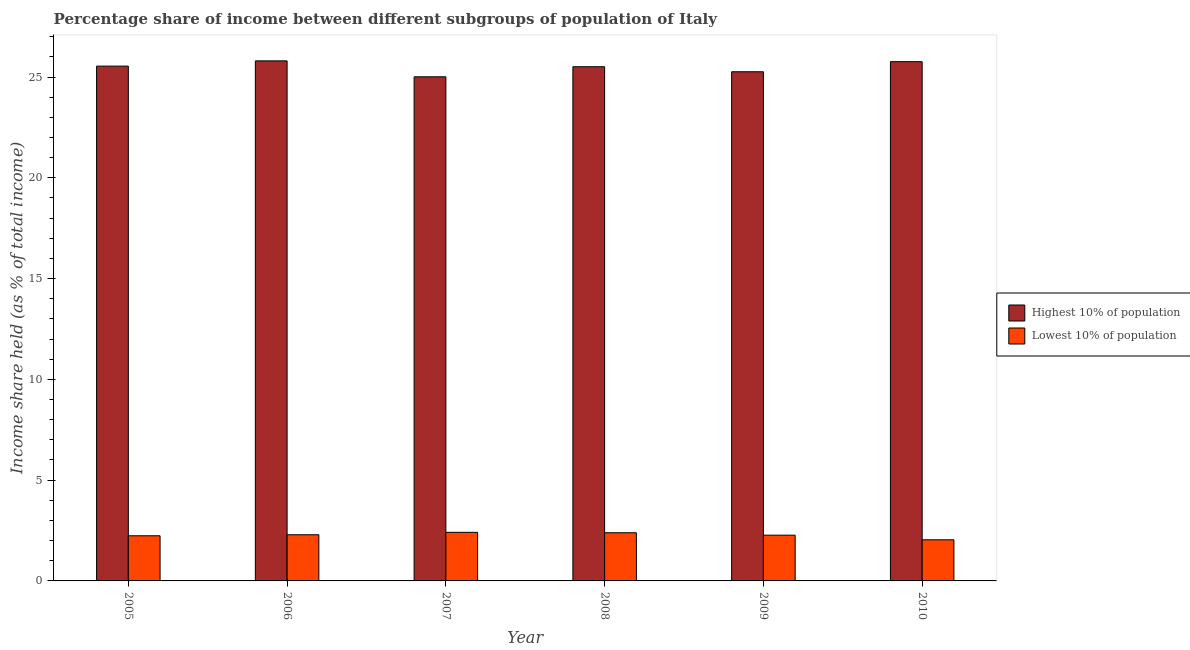How many different coloured bars are there?
Make the answer very short. 2. How many groups of bars are there?
Offer a very short reply. 6. What is the label of the 3rd group of bars from the left?
Offer a very short reply. 2007. What is the income share held by highest 10% of the population in 2008?
Provide a short and direct response. 25.51. Across all years, what is the maximum income share held by highest 10% of the population?
Offer a very short reply. 25.8. Across all years, what is the minimum income share held by lowest 10% of the population?
Your answer should be compact. 2.04. In which year was the income share held by highest 10% of the population minimum?
Offer a terse response. 2007. What is the total income share held by highest 10% of the population in the graph?
Ensure brevity in your answer.  152.88. What is the difference between the income share held by lowest 10% of the population in 2006 and that in 2009?
Provide a succinct answer. 0.02. What is the difference between the income share held by highest 10% of the population in 2005 and the income share held by lowest 10% of the population in 2006?
Provide a succinct answer. -0.26. What is the average income share held by highest 10% of the population per year?
Your answer should be compact. 25.48. In the year 2007, what is the difference between the income share held by lowest 10% of the population and income share held by highest 10% of the population?
Provide a short and direct response. 0. In how many years, is the income share held by highest 10% of the population greater than 1 %?
Make the answer very short. 6. What is the ratio of the income share held by lowest 10% of the population in 2007 to that in 2008?
Give a very brief answer. 1.01. What is the difference between the highest and the second highest income share held by highest 10% of the population?
Offer a very short reply. 0.04. What is the difference between the highest and the lowest income share held by highest 10% of the population?
Provide a short and direct response. 0.79. In how many years, is the income share held by lowest 10% of the population greater than the average income share held by lowest 10% of the population taken over all years?
Your answer should be compact. 3. What does the 2nd bar from the left in 2009 represents?
Keep it short and to the point. Lowest 10% of population. What does the 1st bar from the right in 2009 represents?
Offer a terse response. Lowest 10% of population. How many bars are there?
Your answer should be compact. 12. How many years are there in the graph?
Your answer should be very brief. 6. What is the difference between two consecutive major ticks on the Y-axis?
Ensure brevity in your answer.  5. Does the graph contain grids?
Your response must be concise. No. Where does the legend appear in the graph?
Your answer should be compact. Center right. What is the title of the graph?
Provide a succinct answer. Percentage share of income between different subgroups of population of Italy. Does "Arms imports" appear as one of the legend labels in the graph?
Your answer should be compact. No. What is the label or title of the Y-axis?
Ensure brevity in your answer.  Income share held (as % of total income). What is the Income share held (as % of total income) in Highest 10% of population in 2005?
Your answer should be compact. 25.54. What is the Income share held (as % of total income) in Lowest 10% of population in 2005?
Ensure brevity in your answer.  2.24. What is the Income share held (as % of total income) in Highest 10% of population in 2006?
Provide a succinct answer. 25.8. What is the Income share held (as % of total income) in Lowest 10% of population in 2006?
Your answer should be compact. 2.29. What is the Income share held (as % of total income) of Highest 10% of population in 2007?
Offer a terse response. 25.01. What is the Income share held (as % of total income) in Lowest 10% of population in 2007?
Provide a short and direct response. 2.41. What is the Income share held (as % of total income) of Highest 10% of population in 2008?
Offer a terse response. 25.51. What is the Income share held (as % of total income) in Lowest 10% of population in 2008?
Make the answer very short. 2.39. What is the Income share held (as % of total income) of Highest 10% of population in 2009?
Make the answer very short. 25.26. What is the Income share held (as % of total income) in Lowest 10% of population in 2009?
Give a very brief answer. 2.27. What is the Income share held (as % of total income) in Highest 10% of population in 2010?
Give a very brief answer. 25.76. What is the Income share held (as % of total income) in Lowest 10% of population in 2010?
Provide a short and direct response. 2.04. Across all years, what is the maximum Income share held (as % of total income) of Highest 10% of population?
Offer a very short reply. 25.8. Across all years, what is the maximum Income share held (as % of total income) in Lowest 10% of population?
Make the answer very short. 2.41. Across all years, what is the minimum Income share held (as % of total income) in Highest 10% of population?
Your response must be concise. 25.01. Across all years, what is the minimum Income share held (as % of total income) of Lowest 10% of population?
Your answer should be compact. 2.04. What is the total Income share held (as % of total income) in Highest 10% of population in the graph?
Your response must be concise. 152.88. What is the total Income share held (as % of total income) in Lowest 10% of population in the graph?
Your answer should be compact. 13.64. What is the difference between the Income share held (as % of total income) in Highest 10% of population in 2005 and that in 2006?
Provide a succinct answer. -0.26. What is the difference between the Income share held (as % of total income) of Lowest 10% of population in 2005 and that in 2006?
Make the answer very short. -0.05. What is the difference between the Income share held (as % of total income) of Highest 10% of population in 2005 and that in 2007?
Keep it short and to the point. 0.53. What is the difference between the Income share held (as % of total income) of Lowest 10% of population in 2005 and that in 2007?
Provide a short and direct response. -0.17. What is the difference between the Income share held (as % of total income) of Highest 10% of population in 2005 and that in 2008?
Your response must be concise. 0.03. What is the difference between the Income share held (as % of total income) of Lowest 10% of population in 2005 and that in 2008?
Ensure brevity in your answer.  -0.15. What is the difference between the Income share held (as % of total income) in Highest 10% of population in 2005 and that in 2009?
Ensure brevity in your answer.  0.28. What is the difference between the Income share held (as % of total income) of Lowest 10% of population in 2005 and that in 2009?
Provide a short and direct response. -0.03. What is the difference between the Income share held (as % of total income) in Highest 10% of population in 2005 and that in 2010?
Offer a terse response. -0.22. What is the difference between the Income share held (as % of total income) of Lowest 10% of population in 2005 and that in 2010?
Provide a succinct answer. 0.2. What is the difference between the Income share held (as % of total income) of Highest 10% of population in 2006 and that in 2007?
Offer a terse response. 0.79. What is the difference between the Income share held (as % of total income) of Lowest 10% of population in 2006 and that in 2007?
Provide a short and direct response. -0.12. What is the difference between the Income share held (as % of total income) of Highest 10% of population in 2006 and that in 2008?
Your response must be concise. 0.29. What is the difference between the Income share held (as % of total income) in Lowest 10% of population in 2006 and that in 2008?
Your response must be concise. -0.1. What is the difference between the Income share held (as % of total income) of Highest 10% of population in 2006 and that in 2009?
Your answer should be very brief. 0.54. What is the difference between the Income share held (as % of total income) in Highest 10% of population in 2006 and that in 2010?
Give a very brief answer. 0.04. What is the difference between the Income share held (as % of total income) of Highest 10% of population in 2007 and that in 2008?
Provide a succinct answer. -0.5. What is the difference between the Income share held (as % of total income) of Lowest 10% of population in 2007 and that in 2008?
Provide a short and direct response. 0.02. What is the difference between the Income share held (as % of total income) of Lowest 10% of population in 2007 and that in 2009?
Provide a short and direct response. 0.14. What is the difference between the Income share held (as % of total income) of Highest 10% of population in 2007 and that in 2010?
Make the answer very short. -0.75. What is the difference between the Income share held (as % of total income) in Lowest 10% of population in 2007 and that in 2010?
Offer a terse response. 0.37. What is the difference between the Income share held (as % of total income) of Highest 10% of population in 2008 and that in 2009?
Give a very brief answer. 0.25. What is the difference between the Income share held (as % of total income) in Lowest 10% of population in 2008 and that in 2009?
Offer a terse response. 0.12. What is the difference between the Income share held (as % of total income) in Lowest 10% of population in 2009 and that in 2010?
Provide a short and direct response. 0.23. What is the difference between the Income share held (as % of total income) in Highest 10% of population in 2005 and the Income share held (as % of total income) in Lowest 10% of population in 2006?
Keep it short and to the point. 23.25. What is the difference between the Income share held (as % of total income) of Highest 10% of population in 2005 and the Income share held (as % of total income) of Lowest 10% of population in 2007?
Ensure brevity in your answer.  23.13. What is the difference between the Income share held (as % of total income) in Highest 10% of population in 2005 and the Income share held (as % of total income) in Lowest 10% of population in 2008?
Your answer should be compact. 23.15. What is the difference between the Income share held (as % of total income) of Highest 10% of population in 2005 and the Income share held (as % of total income) of Lowest 10% of population in 2009?
Give a very brief answer. 23.27. What is the difference between the Income share held (as % of total income) in Highest 10% of population in 2006 and the Income share held (as % of total income) in Lowest 10% of population in 2007?
Keep it short and to the point. 23.39. What is the difference between the Income share held (as % of total income) in Highest 10% of population in 2006 and the Income share held (as % of total income) in Lowest 10% of population in 2008?
Your answer should be very brief. 23.41. What is the difference between the Income share held (as % of total income) of Highest 10% of population in 2006 and the Income share held (as % of total income) of Lowest 10% of population in 2009?
Provide a short and direct response. 23.53. What is the difference between the Income share held (as % of total income) of Highest 10% of population in 2006 and the Income share held (as % of total income) of Lowest 10% of population in 2010?
Your answer should be very brief. 23.76. What is the difference between the Income share held (as % of total income) of Highest 10% of population in 2007 and the Income share held (as % of total income) of Lowest 10% of population in 2008?
Make the answer very short. 22.62. What is the difference between the Income share held (as % of total income) in Highest 10% of population in 2007 and the Income share held (as % of total income) in Lowest 10% of population in 2009?
Your answer should be compact. 22.74. What is the difference between the Income share held (as % of total income) of Highest 10% of population in 2007 and the Income share held (as % of total income) of Lowest 10% of population in 2010?
Your answer should be very brief. 22.97. What is the difference between the Income share held (as % of total income) in Highest 10% of population in 2008 and the Income share held (as % of total income) in Lowest 10% of population in 2009?
Make the answer very short. 23.24. What is the difference between the Income share held (as % of total income) in Highest 10% of population in 2008 and the Income share held (as % of total income) in Lowest 10% of population in 2010?
Make the answer very short. 23.47. What is the difference between the Income share held (as % of total income) in Highest 10% of population in 2009 and the Income share held (as % of total income) in Lowest 10% of population in 2010?
Your response must be concise. 23.22. What is the average Income share held (as % of total income) of Highest 10% of population per year?
Offer a very short reply. 25.48. What is the average Income share held (as % of total income) of Lowest 10% of population per year?
Ensure brevity in your answer.  2.27. In the year 2005, what is the difference between the Income share held (as % of total income) of Highest 10% of population and Income share held (as % of total income) of Lowest 10% of population?
Your answer should be compact. 23.3. In the year 2006, what is the difference between the Income share held (as % of total income) in Highest 10% of population and Income share held (as % of total income) in Lowest 10% of population?
Your answer should be very brief. 23.51. In the year 2007, what is the difference between the Income share held (as % of total income) of Highest 10% of population and Income share held (as % of total income) of Lowest 10% of population?
Your response must be concise. 22.6. In the year 2008, what is the difference between the Income share held (as % of total income) of Highest 10% of population and Income share held (as % of total income) of Lowest 10% of population?
Make the answer very short. 23.12. In the year 2009, what is the difference between the Income share held (as % of total income) in Highest 10% of population and Income share held (as % of total income) in Lowest 10% of population?
Make the answer very short. 22.99. In the year 2010, what is the difference between the Income share held (as % of total income) in Highest 10% of population and Income share held (as % of total income) in Lowest 10% of population?
Give a very brief answer. 23.72. What is the ratio of the Income share held (as % of total income) of Highest 10% of population in 2005 to that in 2006?
Keep it short and to the point. 0.99. What is the ratio of the Income share held (as % of total income) in Lowest 10% of population in 2005 to that in 2006?
Your answer should be compact. 0.98. What is the ratio of the Income share held (as % of total income) in Highest 10% of population in 2005 to that in 2007?
Keep it short and to the point. 1.02. What is the ratio of the Income share held (as % of total income) of Lowest 10% of population in 2005 to that in 2007?
Offer a terse response. 0.93. What is the ratio of the Income share held (as % of total income) of Lowest 10% of population in 2005 to that in 2008?
Keep it short and to the point. 0.94. What is the ratio of the Income share held (as % of total income) in Highest 10% of population in 2005 to that in 2009?
Offer a very short reply. 1.01. What is the ratio of the Income share held (as % of total income) of Lowest 10% of population in 2005 to that in 2009?
Give a very brief answer. 0.99. What is the ratio of the Income share held (as % of total income) of Highest 10% of population in 2005 to that in 2010?
Your answer should be compact. 0.99. What is the ratio of the Income share held (as % of total income) in Lowest 10% of population in 2005 to that in 2010?
Keep it short and to the point. 1.1. What is the ratio of the Income share held (as % of total income) of Highest 10% of population in 2006 to that in 2007?
Your answer should be compact. 1.03. What is the ratio of the Income share held (as % of total income) in Lowest 10% of population in 2006 to that in 2007?
Provide a short and direct response. 0.95. What is the ratio of the Income share held (as % of total income) of Highest 10% of population in 2006 to that in 2008?
Ensure brevity in your answer.  1.01. What is the ratio of the Income share held (as % of total income) of Lowest 10% of population in 2006 to that in 2008?
Your answer should be compact. 0.96. What is the ratio of the Income share held (as % of total income) of Highest 10% of population in 2006 to that in 2009?
Provide a succinct answer. 1.02. What is the ratio of the Income share held (as % of total income) of Lowest 10% of population in 2006 to that in 2009?
Your answer should be compact. 1.01. What is the ratio of the Income share held (as % of total income) of Highest 10% of population in 2006 to that in 2010?
Provide a succinct answer. 1. What is the ratio of the Income share held (as % of total income) in Lowest 10% of population in 2006 to that in 2010?
Your answer should be very brief. 1.12. What is the ratio of the Income share held (as % of total income) of Highest 10% of population in 2007 to that in 2008?
Offer a terse response. 0.98. What is the ratio of the Income share held (as % of total income) in Lowest 10% of population in 2007 to that in 2008?
Your response must be concise. 1.01. What is the ratio of the Income share held (as % of total income) of Highest 10% of population in 2007 to that in 2009?
Your answer should be very brief. 0.99. What is the ratio of the Income share held (as % of total income) of Lowest 10% of population in 2007 to that in 2009?
Provide a succinct answer. 1.06. What is the ratio of the Income share held (as % of total income) in Highest 10% of population in 2007 to that in 2010?
Provide a succinct answer. 0.97. What is the ratio of the Income share held (as % of total income) of Lowest 10% of population in 2007 to that in 2010?
Offer a very short reply. 1.18. What is the ratio of the Income share held (as % of total income) in Highest 10% of population in 2008 to that in 2009?
Give a very brief answer. 1.01. What is the ratio of the Income share held (as % of total income) of Lowest 10% of population in 2008 to that in 2009?
Provide a short and direct response. 1.05. What is the ratio of the Income share held (as % of total income) of Highest 10% of population in 2008 to that in 2010?
Your answer should be very brief. 0.99. What is the ratio of the Income share held (as % of total income) of Lowest 10% of population in 2008 to that in 2010?
Ensure brevity in your answer.  1.17. What is the ratio of the Income share held (as % of total income) in Highest 10% of population in 2009 to that in 2010?
Your answer should be very brief. 0.98. What is the ratio of the Income share held (as % of total income) of Lowest 10% of population in 2009 to that in 2010?
Provide a succinct answer. 1.11. What is the difference between the highest and the second highest Income share held (as % of total income) in Lowest 10% of population?
Provide a short and direct response. 0.02. What is the difference between the highest and the lowest Income share held (as % of total income) of Highest 10% of population?
Make the answer very short. 0.79. What is the difference between the highest and the lowest Income share held (as % of total income) in Lowest 10% of population?
Your answer should be very brief. 0.37. 